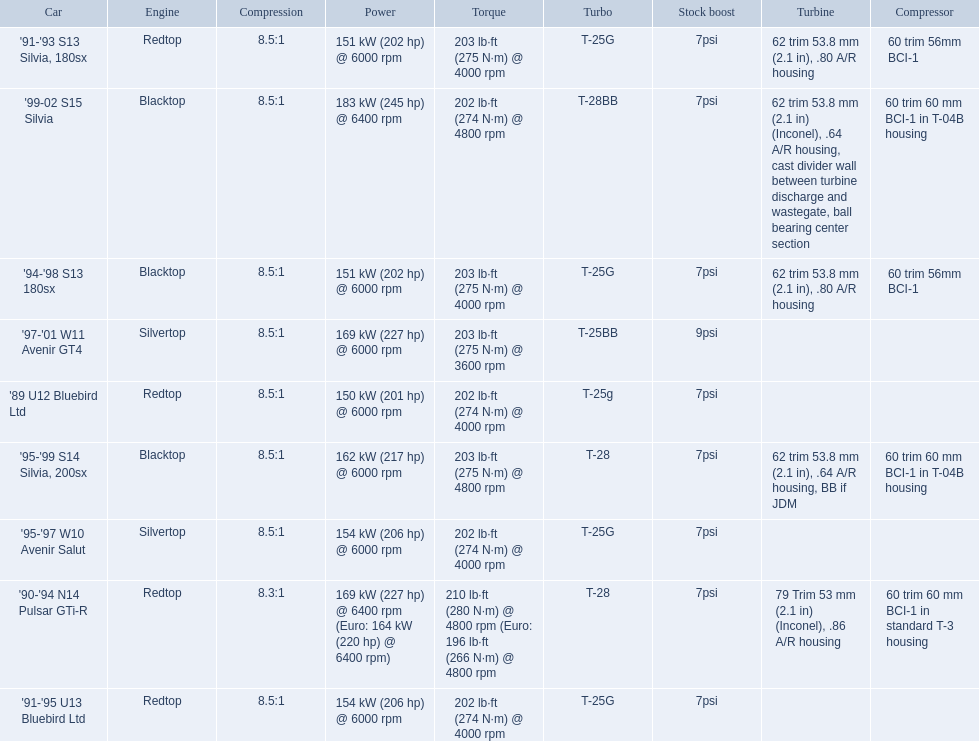What are all of the nissan cars? '89 U12 Bluebird Ltd, '91-'95 U13 Bluebird Ltd, '95-'97 W10 Avenir Salut, '97-'01 W11 Avenir GT4, '90-'94 N14 Pulsar GTi-R, '91-'93 S13 Silvia, 180sx, '94-'98 S13 180sx, '95-'99 S14 Silvia, 200sx, '99-02 S15 Silvia. Of these cars, which one is a '90-'94 n14 pulsar gti-r? '90-'94 N14 Pulsar GTi-R. What is the compression of this car? 8.3:1. 